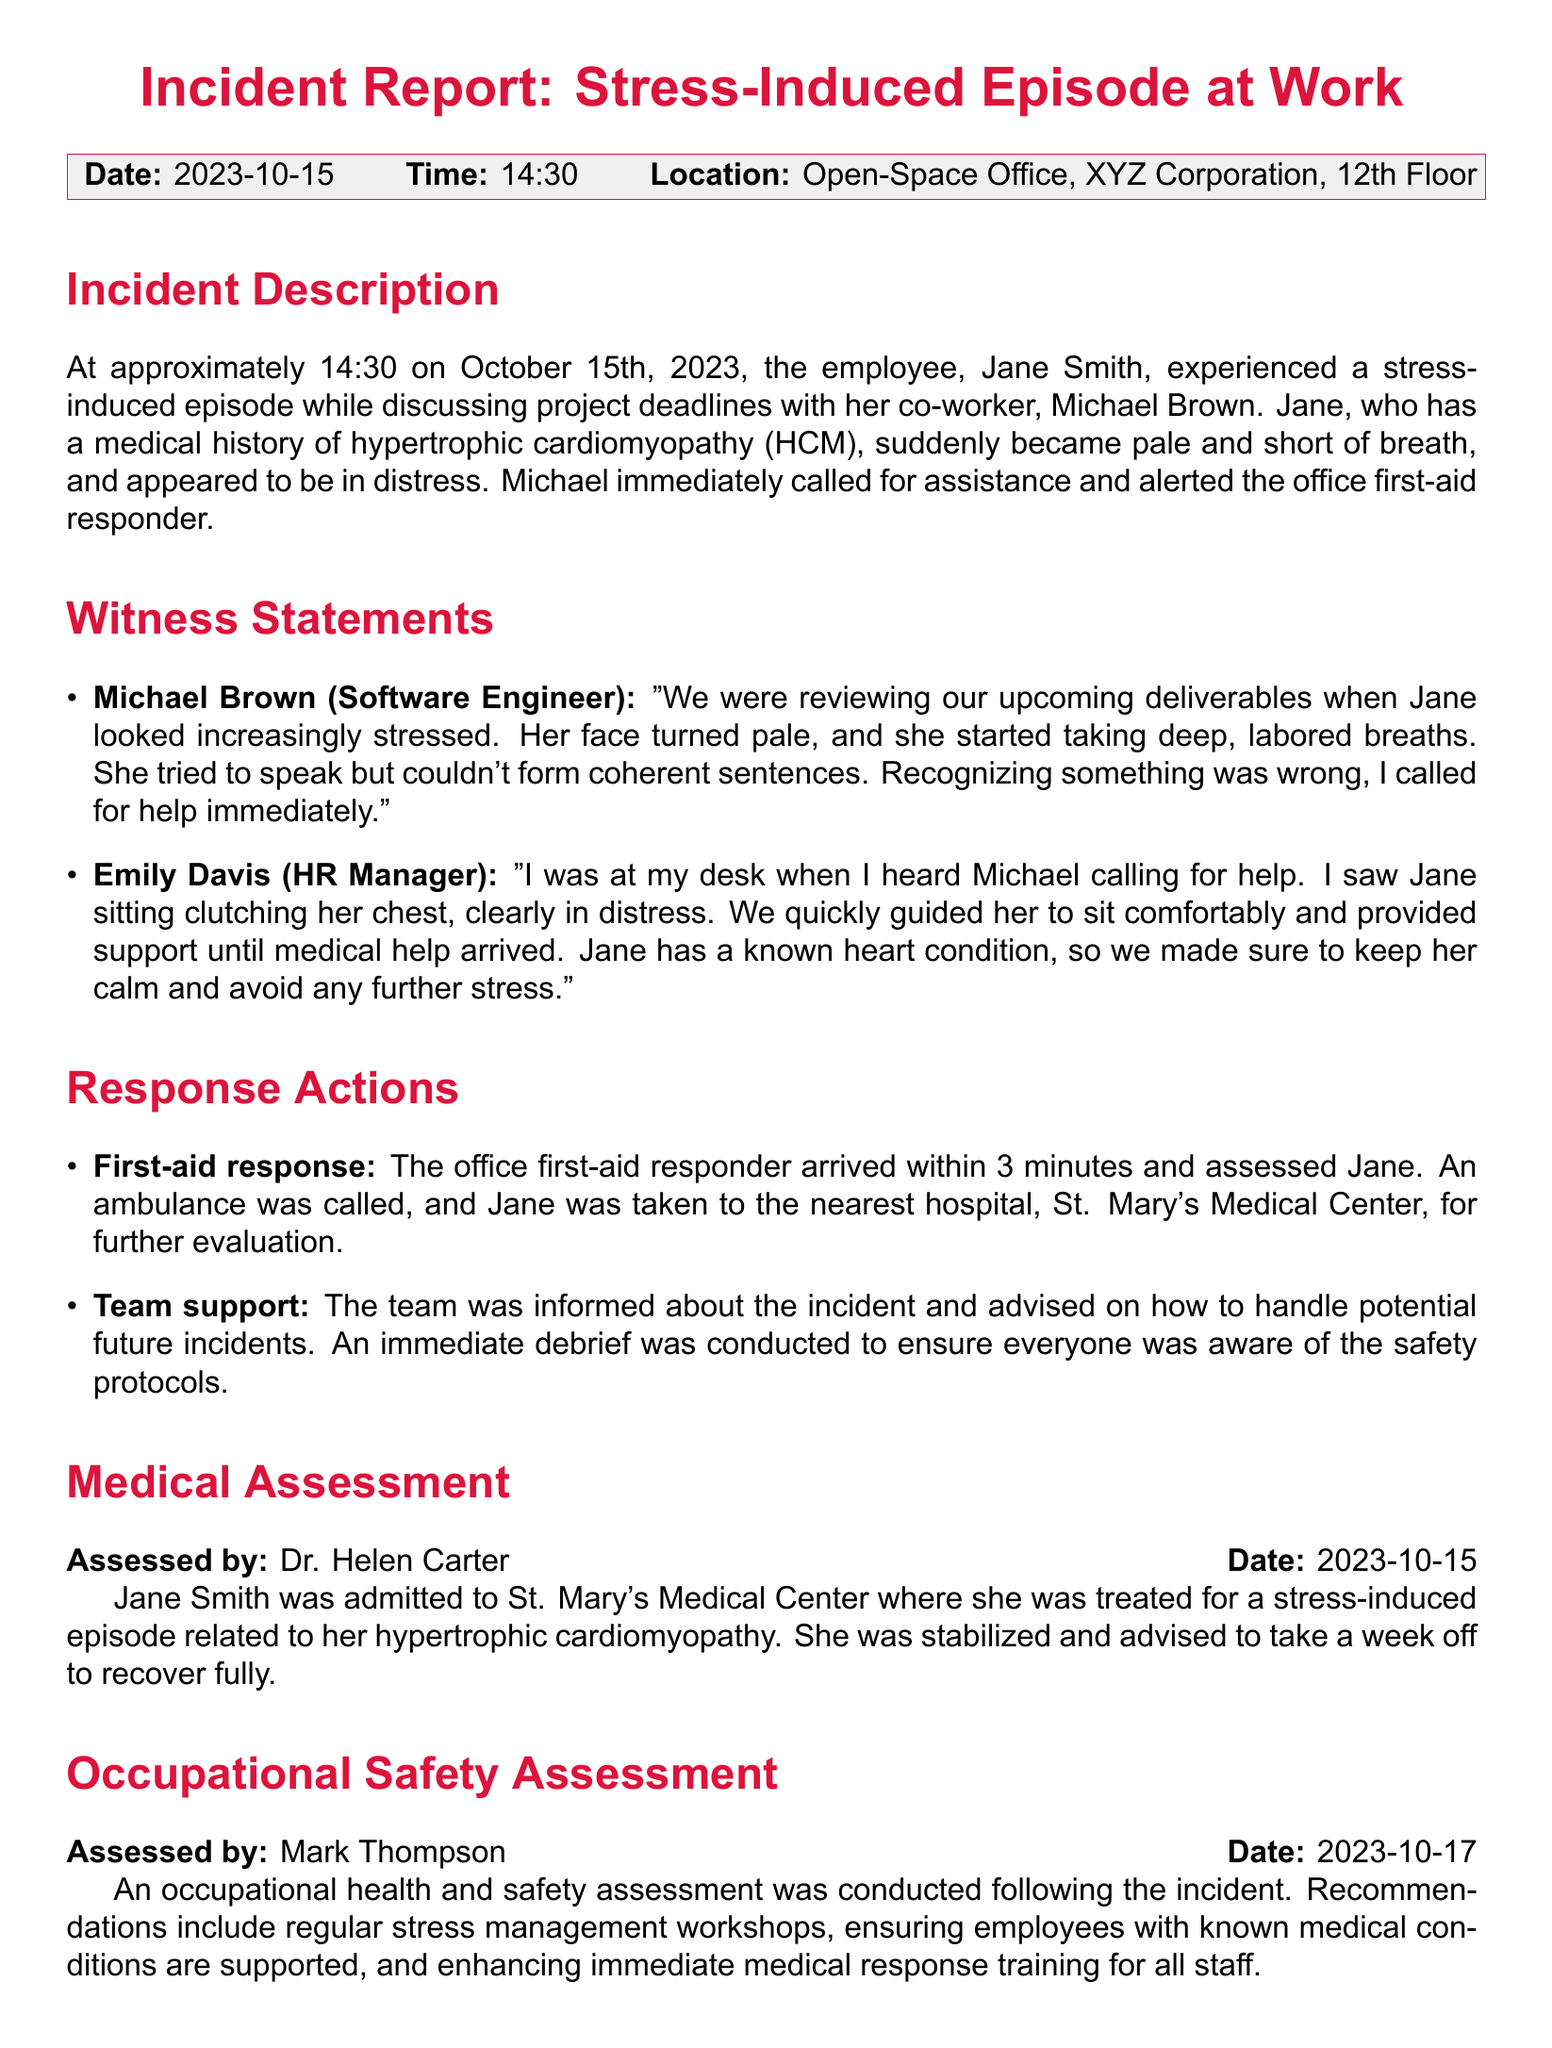what is the date of the incident? The date of the incident is clearly stated in the document as October 15th, 2023.
Answer: October 15th, 2023 who is the employee that experienced the episode? The document identifies the employee who experienced the episode as Jane Smith.
Answer: Jane Smith what was the location of the incident? The incident location is specified as the Open-Space Office, XYZ Corporation, 12th Floor.
Answer: Open-Space Office, XYZ Corporation, 12th Floor what medical condition does Jane have? Jane's medical condition is mentioned as hypertrophic cardiomyopathy (HCM) in the incident report.
Answer: hypertrophic cardiomyopathy (HCM) how long was Jane advised to take off work? According to the medical assessment, Jane was advised to take a week off to recover fully.
Answer: a week who assessed Jane after the incident? The document states that Jane was assessed by Dr. Helen Carter at St. Mary's Medical Center.
Answer: Dr. Helen Carter what was a recommendation from the occupational safety assessment? The recommendations included regular stress management workshops as noted in the document.
Answer: regular stress management workshops who reported the incident? The report credits John Doe, Team Leader, Software Development, as the person who reported the incident.
Answer: John Doe 